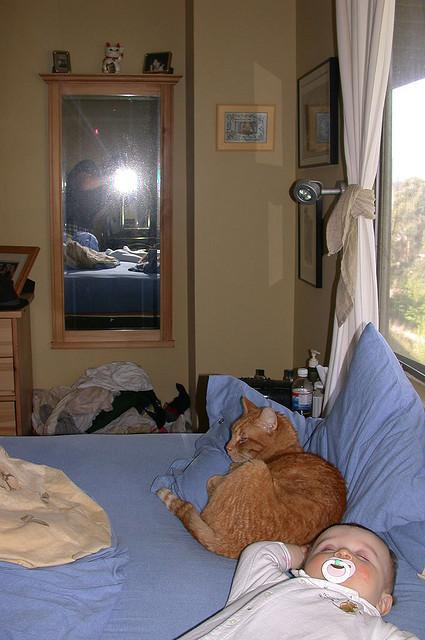What is the cause of the bright spot in the center of the mirror on the wall? Please explain your reasoning. camera flash. The photographer is visible in the image and the bright spot is consistent with their location and the tool they would be using to take the picture. 